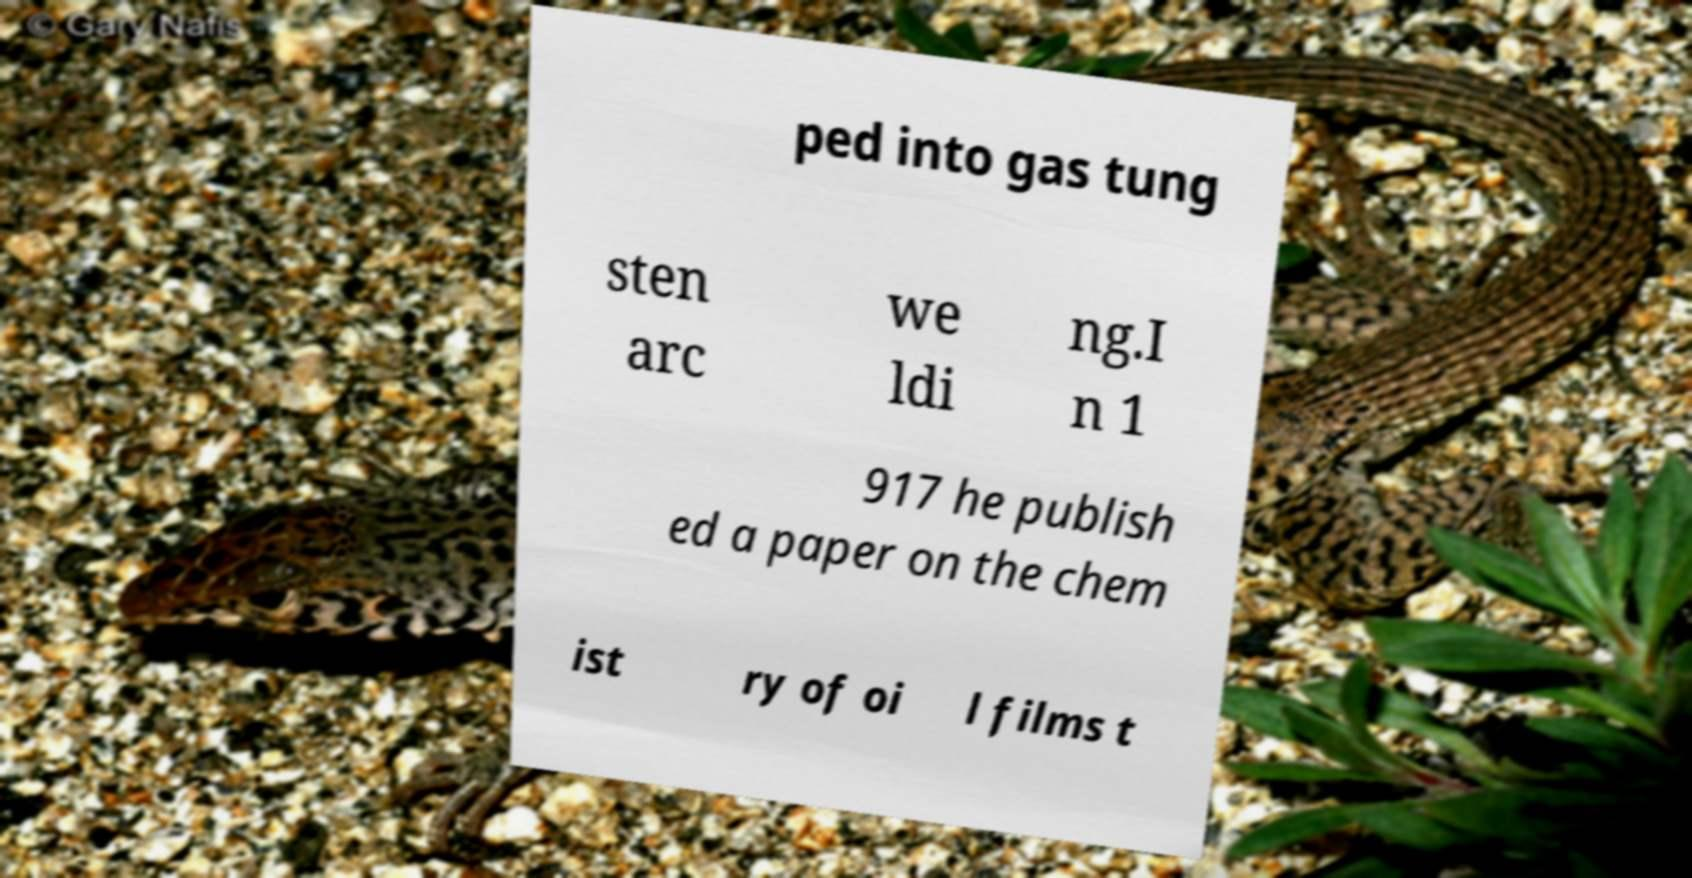For documentation purposes, I need the text within this image transcribed. Could you provide that? ped into gas tung sten arc we ldi ng.I n 1 917 he publish ed a paper on the chem ist ry of oi l films t 